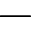Convert formula to latex. <formula><loc_0><loc_0><loc_500><loc_500>-</formula> 